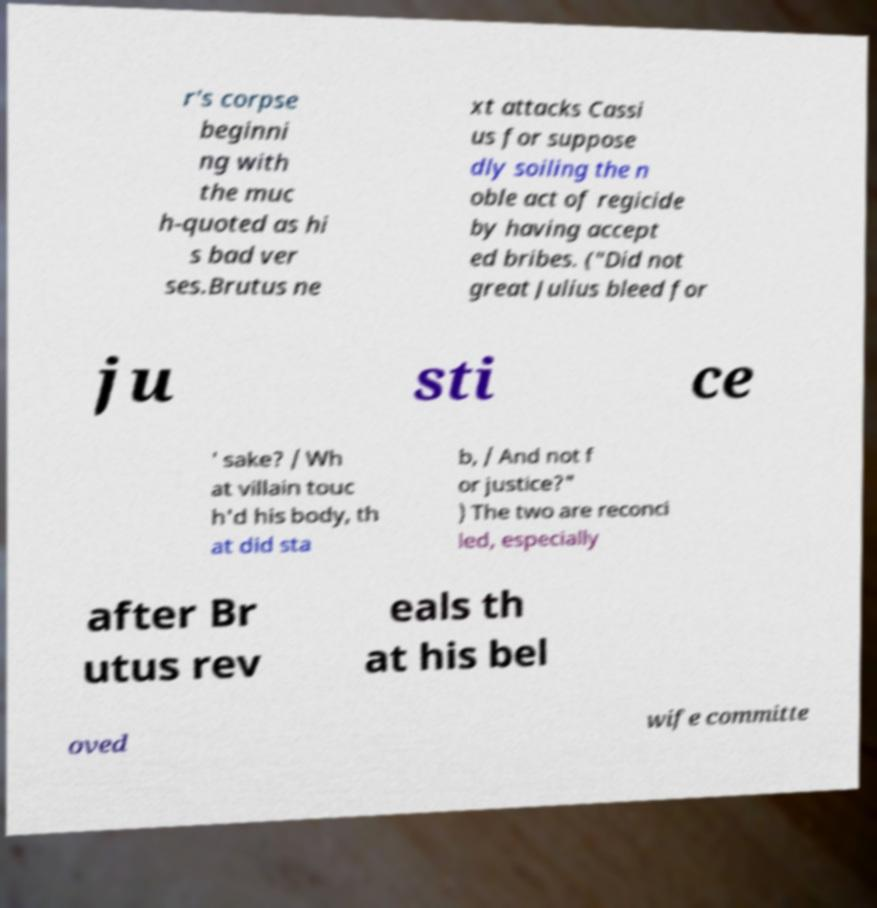Please read and relay the text visible in this image. What does it say? r's corpse beginni ng with the muc h-quoted as hi s bad ver ses.Brutus ne xt attacks Cassi us for suppose dly soiling the n oble act of regicide by having accept ed bribes. ("Did not great Julius bleed for ju sti ce ' sake? / Wh at villain touc h'd his body, th at did sta b, / And not f or justice?" ) The two are reconci led, especially after Br utus rev eals th at his bel oved wife committe 